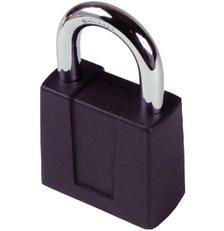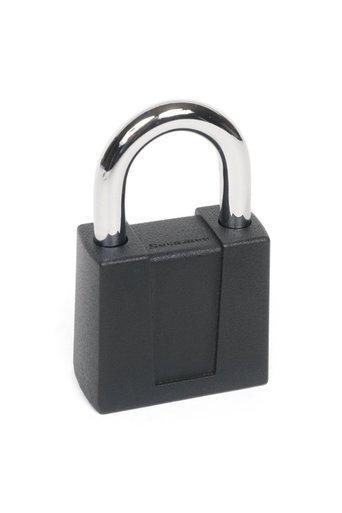The first image is the image on the left, the second image is the image on the right. Analyze the images presented: Is the assertion "Two locks are both roughly square shaped, but the metal loop of one lock is much longer than the loop of the other lock." valid? Answer yes or no. No. The first image is the image on the left, the second image is the image on the right. Assess this claim about the two images: "The body of both locks is made of gold colored metal.". Correct or not? Answer yes or no. No. 